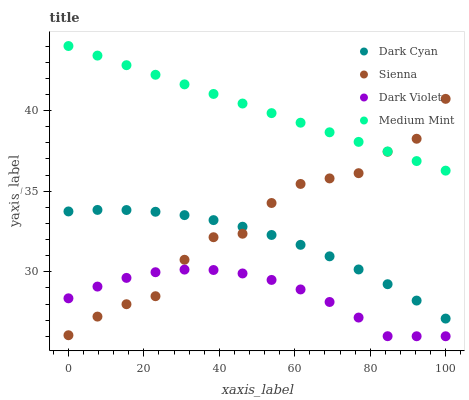Does Dark Violet have the minimum area under the curve?
Answer yes or no. Yes. Does Medium Mint have the maximum area under the curve?
Answer yes or no. Yes. Does Sienna have the minimum area under the curve?
Answer yes or no. No. Does Sienna have the maximum area under the curve?
Answer yes or no. No. Is Medium Mint the smoothest?
Answer yes or no. Yes. Is Sienna the roughest?
Answer yes or no. Yes. Is Dark Violet the smoothest?
Answer yes or no. No. Is Dark Violet the roughest?
Answer yes or no. No. Does Dark Violet have the lowest value?
Answer yes or no. Yes. Does Sienna have the lowest value?
Answer yes or no. No. Does Medium Mint have the highest value?
Answer yes or no. Yes. Does Sienna have the highest value?
Answer yes or no. No. Is Dark Violet less than Dark Cyan?
Answer yes or no. Yes. Is Dark Cyan greater than Dark Violet?
Answer yes or no. Yes. Does Sienna intersect Dark Violet?
Answer yes or no. Yes. Is Sienna less than Dark Violet?
Answer yes or no. No. Is Sienna greater than Dark Violet?
Answer yes or no. No. Does Dark Violet intersect Dark Cyan?
Answer yes or no. No. 